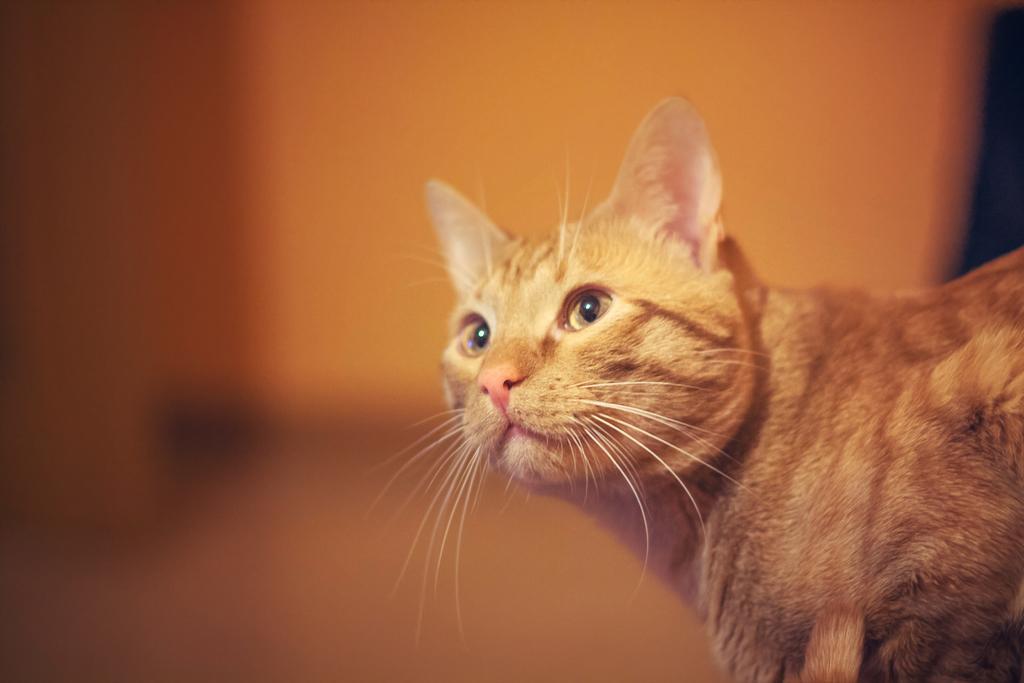Could you give a brief overview of what you see in this image? In this image we can see a cat and in the background it looks like a wall. 